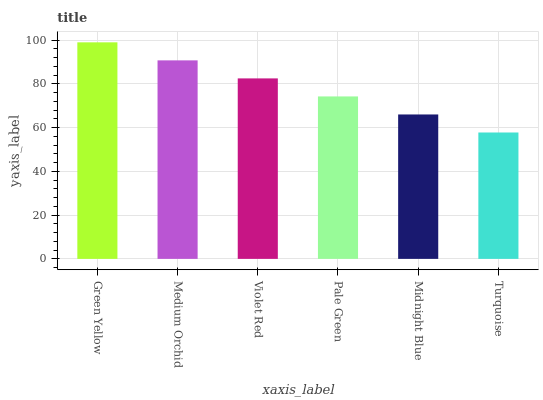Is Turquoise the minimum?
Answer yes or no. Yes. Is Green Yellow the maximum?
Answer yes or no. Yes. Is Medium Orchid the minimum?
Answer yes or no. No. Is Medium Orchid the maximum?
Answer yes or no. No. Is Green Yellow greater than Medium Orchid?
Answer yes or no. Yes. Is Medium Orchid less than Green Yellow?
Answer yes or no. Yes. Is Medium Orchid greater than Green Yellow?
Answer yes or no. No. Is Green Yellow less than Medium Orchid?
Answer yes or no. No. Is Violet Red the high median?
Answer yes or no. Yes. Is Pale Green the low median?
Answer yes or no. Yes. Is Medium Orchid the high median?
Answer yes or no. No. Is Turquoise the low median?
Answer yes or no. No. 